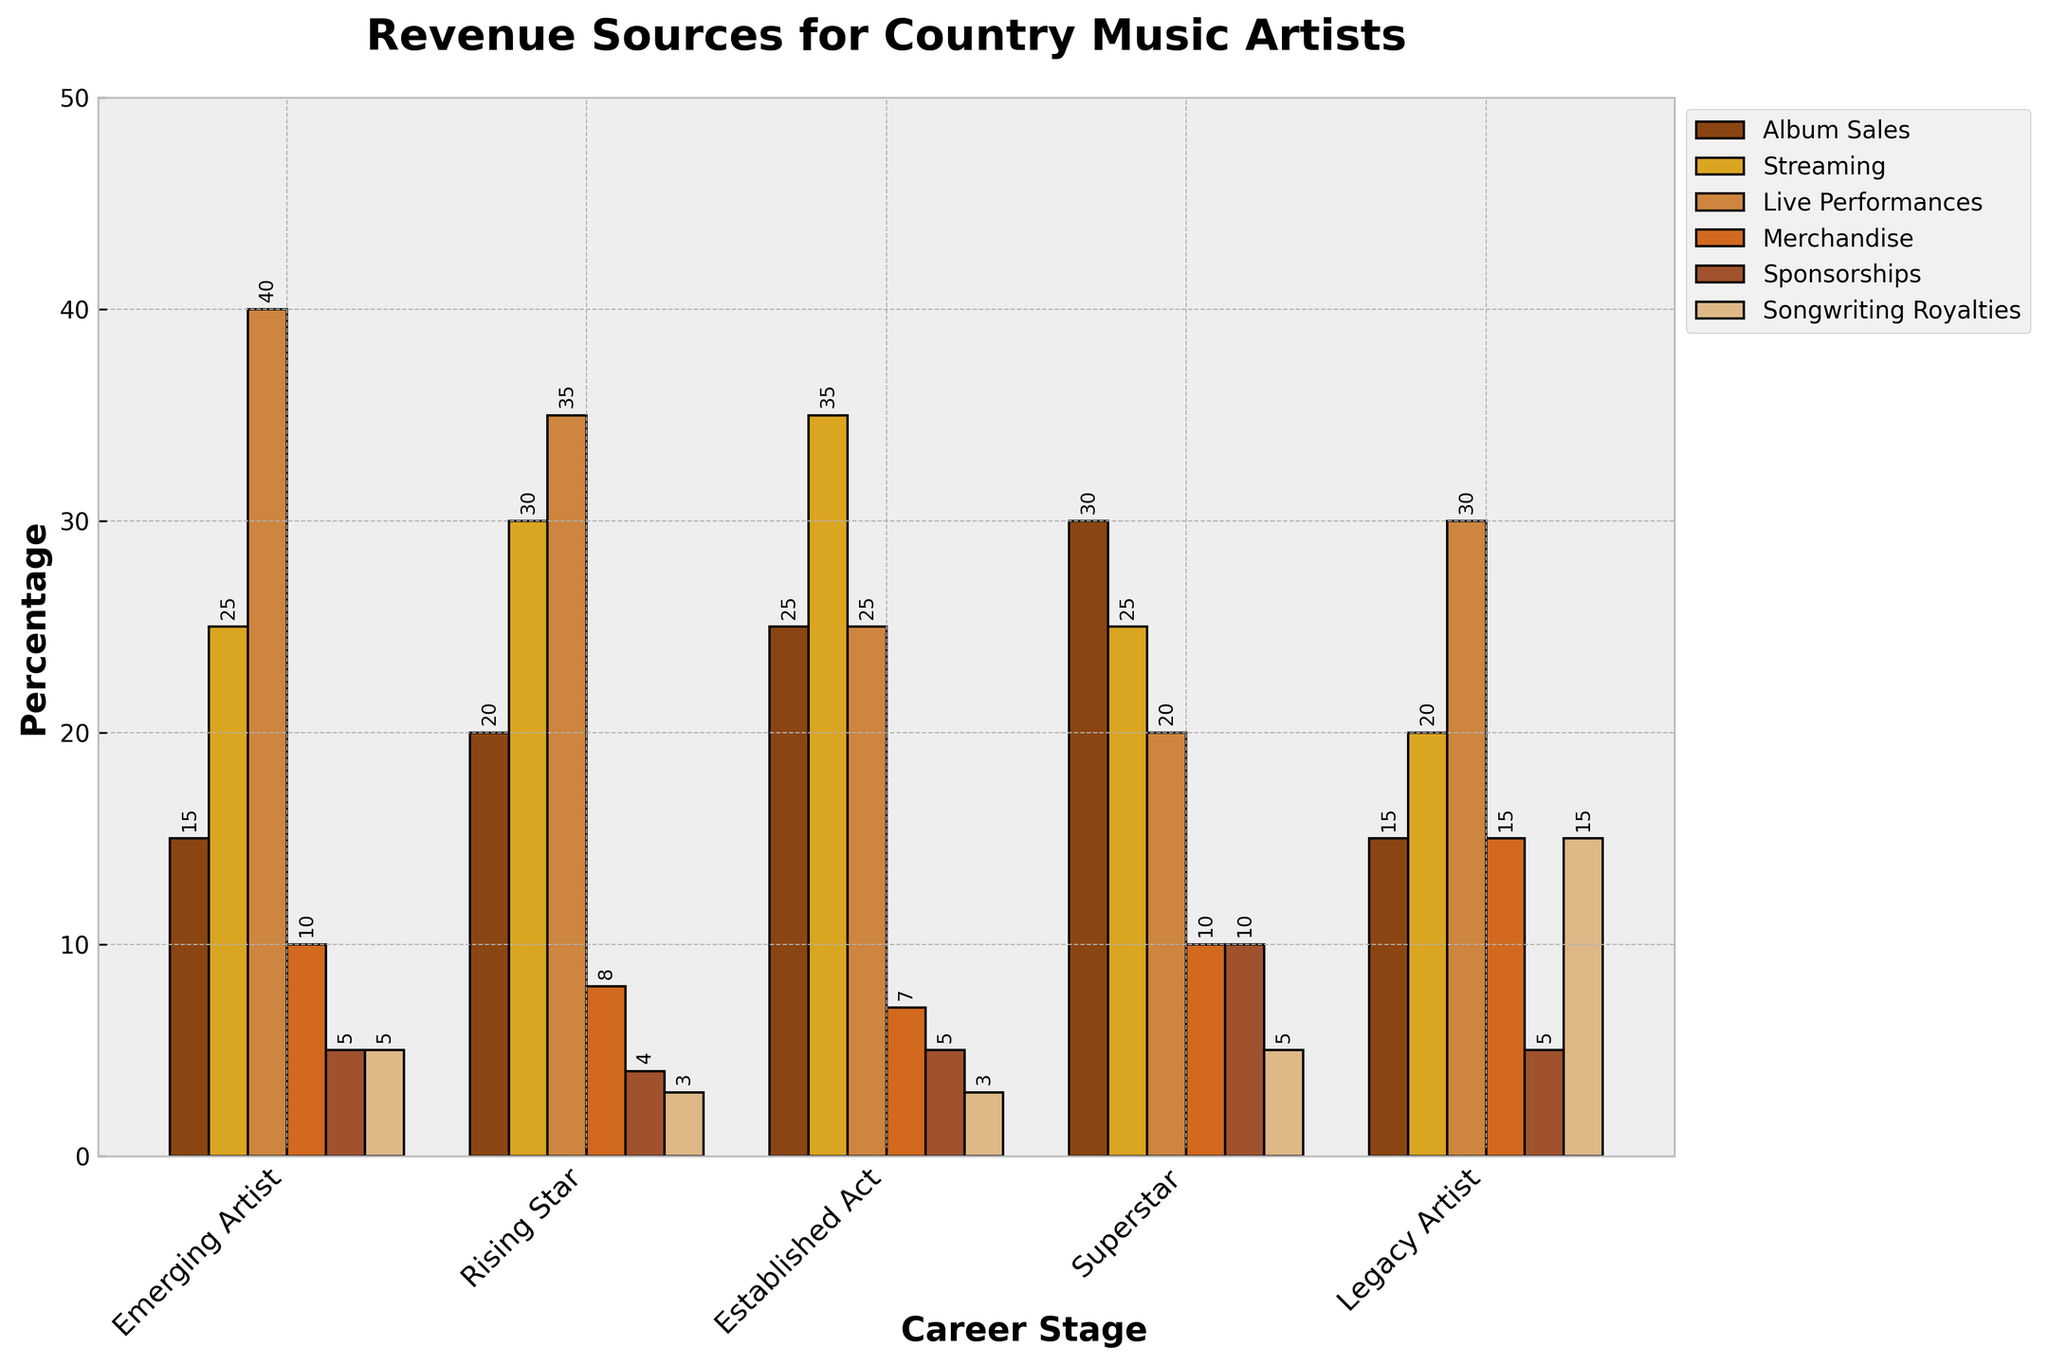What is the primary revenue source for Emerging Artists? The bar representing Live Performances is the tallest among all revenue sources for Emerging Artists, indicating it is the primary revenue source.
Answer: Live Performances Which career stage has the highest percentage of revenue from Merchandise? The bar for Merchandise is tallest for Legacy Artists compared to other career stages.
Answer: Legacy Artist How does the percentage of revenue from Songwriting Royalties for Legacy Artists compare to that of Superstars? The bar for Songwriting Royalties is higher for Legacy Artists (15%) than for Superstars (5%).
Answer: Legacy Artists have a higher percentage What is the total percentage of revenue from Album Sales and Streaming for Rising Stars? Summing the percentages of Album Sales (20%) and Streaming (30%) for Rising Stars, we get 20% + 30% = 50%.
Answer: 50% Which revenue source decreases most noticeably from Emerging Artists to Superstars? Live Performances revenue decreases from 40% for Emerging Artists to 20% for Superstars.
Answer: Live Performances Which revenue sources are equal for Emerging Artists and Established Acts? Both Emerging Artists and Established Acts have 5% revenue from Sponsorships and 3% from Songwriting Royalties.
Answer: Sponsorships and Songwriting Royalties For which career stage does Streaming constitute the largest share of revenue? The tallest bar representing Streaming is seen for Established Acts at 35%.
Answer: Established Act Which career stage has the lowest percentage of revenue coming from Album Sales? The bar for Album Sales is the lowest for Emerging Artists, at 15%.
Answer: Emerging Artist How does the combination of Live Performances and Merchandise revenue for Superstars compare to the same combination for Legacy Artists? For Superstars, the combination is 20% (Live Performances) + 10% (Merchandise) = 30%. For Legacy Artists, it is 30% (Live Performances) + 15% (Merchandise) = 45%.
Answer: Legacy Artists have a higher combined percentage Which revenue source remains constant across all career stages except for Superstars? Songwriting Royalties remain constant at 3% for all stages except for Superstars, where it is 5%.
Answer: Songwriting Royalties 